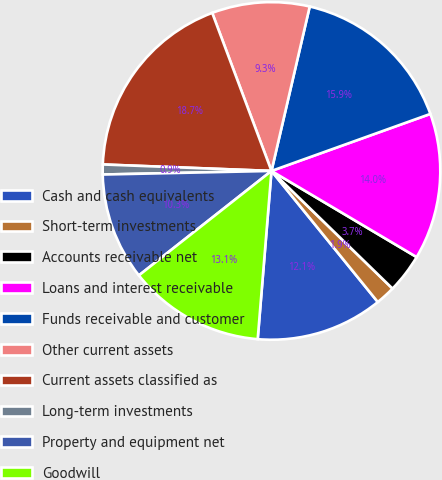Convert chart to OTSL. <chart><loc_0><loc_0><loc_500><loc_500><pie_chart><fcel>Cash and cash equivalents<fcel>Short-term investments<fcel>Accounts receivable net<fcel>Loans and interest receivable<fcel>Funds receivable and customer<fcel>Other current assets<fcel>Current assets classified as<fcel>Long-term investments<fcel>Property and equipment net<fcel>Goodwill<nl><fcel>12.15%<fcel>1.88%<fcel>3.75%<fcel>14.01%<fcel>15.88%<fcel>9.35%<fcel>18.68%<fcel>0.95%<fcel>10.28%<fcel>13.08%<nl></chart> 